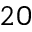<formula> <loc_0><loc_0><loc_500><loc_500>2 0</formula> 